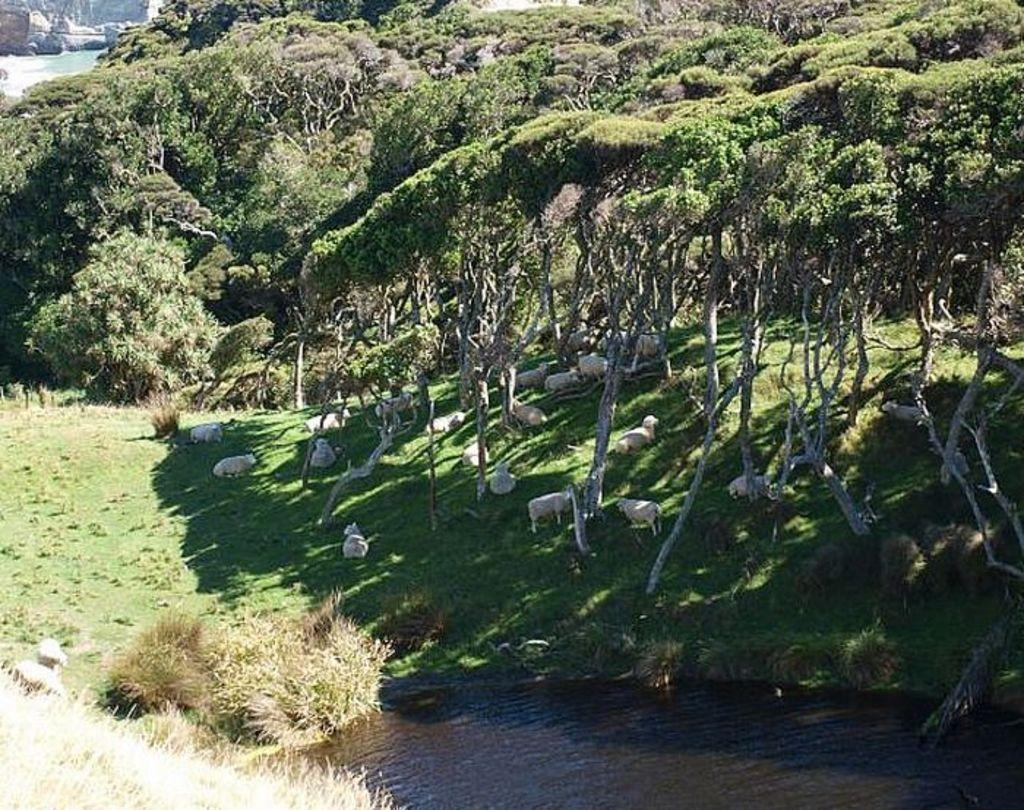What type of vegetation can be seen in the image? There are trees in the image. What animals are present on the ground in the image? There are sheep on the ground in the image. What body of water is visible at the bottom of the image? There is a small pond at the bottom of the image. What trick can be seen being performed by the sheep in the image? There is no trick being performed by the sheep in the image; they are simply grazing on the ground. What does the land in the image represent in terms of regret? The image does not convey any sense of regret, and there is no indication that the land has any symbolic meaning related to regret. 